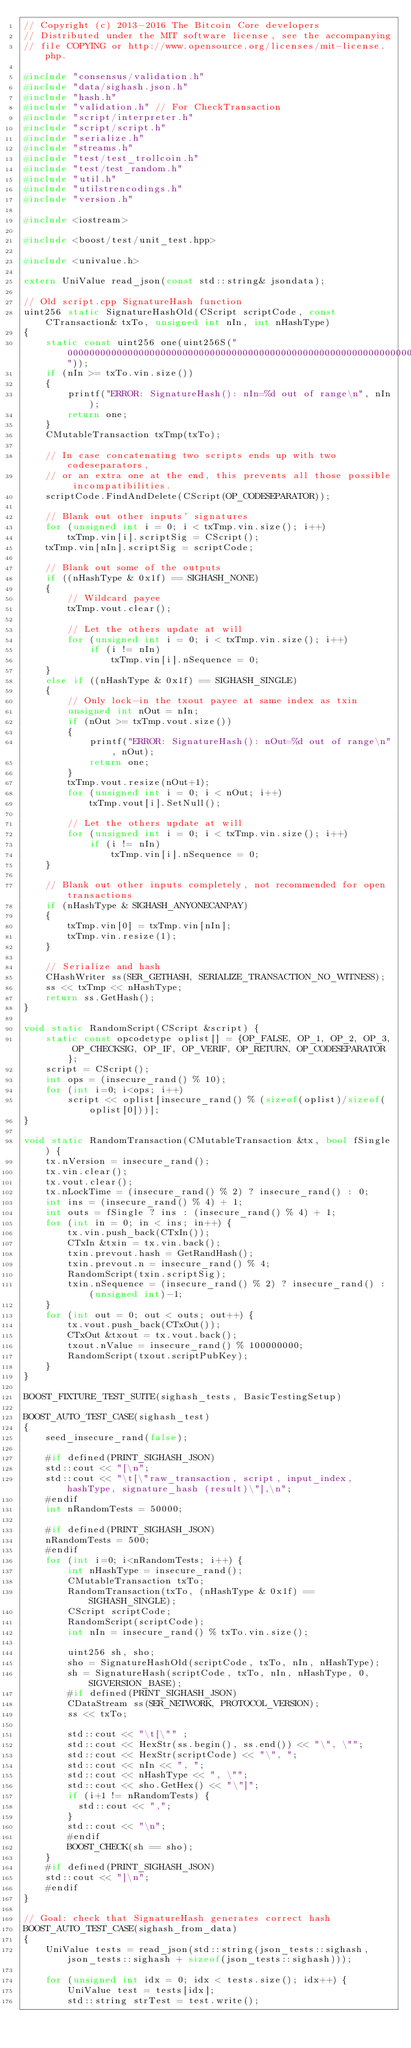<code> <loc_0><loc_0><loc_500><loc_500><_C++_>// Copyright (c) 2013-2016 The Bitcoin Core developers
// Distributed under the MIT software license, see the accompanying
// file COPYING or http://www.opensource.org/licenses/mit-license.php.

#include "consensus/validation.h"
#include "data/sighash.json.h"
#include "hash.h"
#include "validation.h" // For CheckTransaction
#include "script/interpreter.h"
#include "script/script.h"
#include "serialize.h"
#include "streams.h"
#include "test/test_trollcoin.h"
#include "test/test_random.h"
#include "util.h"
#include "utilstrencodings.h"
#include "version.h"

#include <iostream>

#include <boost/test/unit_test.hpp>

#include <univalue.h>

extern UniValue read_json(const std::string& jsondata);

// Old script.cpp SignatureHash function
uint256 static SignatureHashOld(CScript scriptCode, const CTransaction& txTo, unsigned int nIn, int nHashType)
{
    static const uint256 one(uint256S("0000000000000000000000000000000000000000000000000000000000000001"));
    if (nIn >= txTo.vin.size())
    {
        printf("ERROR: SignatureHash(): nIn=%d out of range\n", nIn);
        return one;
    }
    CMutableTransaction txTmp(txTo);

    // In case concatenating two scripts ends up with two codeseparators,
    // or an extra one at the end, this prevents all those possible incompatibilities.
    scriptCode.FindAndDelete(CScript(OP_CODESEPARATOR));

    // Blank out other inputs' signatures
    for (unsigned int i = 0; i < txTmp.vin.size(); i++)
        txTmp.vin[i].scriptSig = CScript();
    txTmp.vin[nIn].scriptSig = scriptCode;

    // Blank out some of the outputs
    if ((nHashType & 0x1f) == SIGHASH_NONE)
    {
        // Wildcard payee
        txTmp.vout.clear();

        // Let the others update at will
        for (unsigned int i = 0; i < txTmp.vin.size(); i++)
            if (i != nIn)
                txTmp.vin[i].nSequence = 0;
    }
    else if ((nHashType & 0x1f) == SIGHASH_SINGLE)
    {
        // Only lock-in the txout payee at same index as txin
        unsigned int nOut = nIn;
        if (nOut >= txTmp.vout.size())
        {
            printf("ERROR: SignatureHash(): nOut=%d out of range\n", nOut);
            return one;
        }
        txTmp.vout.resize(nOut+1);
        for (unsigned int i = 0; i < nOut; i++)
            txTmp.vout[i].SetNull();

        // Let the others update at will
        for (unsigned int i = 0; i < txTmp.vin.size(); i++)
            if (i != nIn)
                txTmp.vin[i].nSequence = 0;
    }

    // Blank out other inputs completely, not recommended for open transactions
    if (nHashType & SIGHASH_ANYONECANPAY)
    {
        txTmp.vin[0] = txTmp.vin[nIn];
        txTmp.vin.resize(1);
    }

    // Serialize and hash
    CHashWriter ss(SER_GETHASH, SERIALIZE_TRANSACTION_NO_WITNESS);
    ss << txTmp << nHashType;
    return ss.GetHash();
}

void static RandomScript(CScript &script) {
    static const opcodetype oplist[] = {OP_FALSE, OP_1, OP_2, OP_3, OP_CHECKSIG, OP_IF, OP_VERIF, OP_RETURN, OP_CODESEPARATOR};
    script = CScript();
    int ops = (insecure_rand() % 10);
    for (int i=0; i<ops; i++)
        script << oplist[insecure_rand() % (sizeof(oplist)/sizeof(oplist[0]))];
}

void static RandomTransaction(CMutableTransaction &tx, bool fSingle) {
    tx.nVersion = insecure_rand();
    tx.vin.clear();
    tx.vout.clear();
    tx.nLockTime = (insecure_rand() % 2) ? insecure_rand() : 0;
    int ins = (insecure_rand() % 4) + 1;
    int outs = fSingle ? ins : (insecure_rand() % 4) + 1;
    for (int in = 0; in < ins; in++) {
        tx.vin.push_back(CTxIn());
        CTxIn &txin = tx.vin.back();
        txin.prevout.hash = GetRandHash();
        txin.prevout.n = insecure_rand() % 4;
        RandomScript(txin.scriptSig);
        txin.nSequence = (insecure_rand() % 2) ? insecure_rand() : (unsigned int)-1;
    }
    for (int out = 0; out < outs; out++) {
        tx.vout.push_back(CTxOut());
        CTxOut &txout = tx.vout.back();
        txout.nValue = insecure_rand() % 100000000;
        RandomScript(txout.scriptPubKey);
    }
}

BOOST_FIXTURE_TEST_SUITE(sighash_tests, BasicTestingSetup)

BOOST_AUTO_TEST_CASE(sighash_test)
{
    seed_insecure_rand(false);

    #if defined(PRINT_SIGHASH_JSON)
    std::cout << "[\n";
    std::cout << "\t[\"raw_transaction, script, input_index, hashType, signature_hash (result)\"],\n";
    #endif
    int nRandomTests = 50000;

    #if defined(PRINT_SIGHASH_JSON)
    nRandomTests = 500;
    #endif
    for (int i=0; i<nRandomTests; i++) {
        int nHashType = insecure_rand();
        CMutableTransaction txTo;
        RandomTransaction(txTo, (nHashType & 0x1f) == SIGHASH_SINGLE);
        CScript scriptCode;
        RandomScript(scriptCode);
        int nIn = insecure_rand() % txTo.vin.size();

        uint256 sh, sho;
        sho = SignatureHashOld(scriptCode, txTo, nIn, nHashType);
        sh = SignatureHash(scriptCode, txTo, nIn, nHashType, 0, SIGVERSION_BASE);
        #if defined(PRINT_SIGHASH_JSON)
        CDataStream ss(SER_NETWORK, PROTOCOL_VERSION);
        ss << txTo;

        std::cout << "\t[\"" ;
        std::cout << HexStr(ss.begin(), ss.end()) << "\", \"";
        std::cout << HexStr(scriptCode) << "\", ";
        std::cout << nIn << ", ";
        std::cout << nHashType << ", \"";
        std::cout << sho.GetHex() << "\"]";
        if (i+1 != nRandomTests) {
          std::cout << ",";
        }
        std::cout << "\n";
        #endif
        BOOST_CHECK(sh == sho);
    }
    #if defined(PRINT_SIGHASH_JSON)
    std::cout << "]\n";
    #endif
}

// Goal: check that SignatureHash generates correct hash
BOOST_AUTO_TEST_CASE(sighash_from_data)
{
    UniValue tests = read_json(std::string(json_tests::sighash, json_tests::sighash + sizeof(json_tests::sighash)));

    for (unsigned int idx = 0; idx < tests.size(); idx++) {
        UniValue test = tests[idx];
        std::string strTest = test.write();</code> 